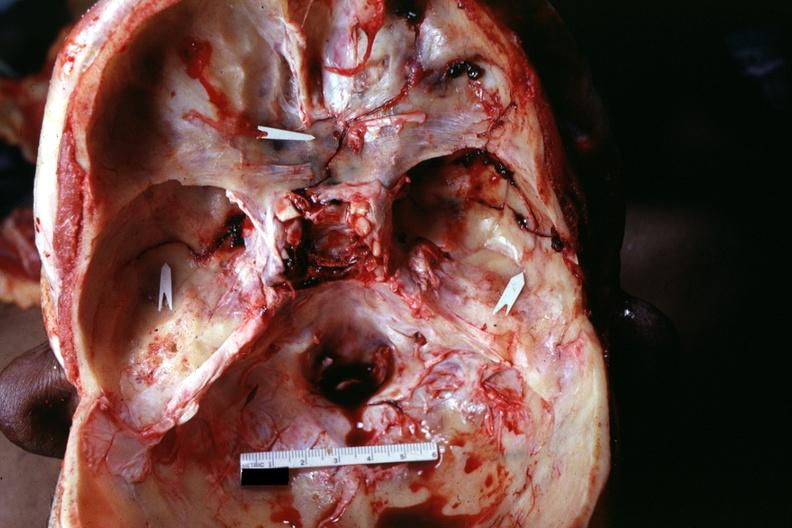s bone, calvarium present?
Answer the question using a single word or phrase. Yes 